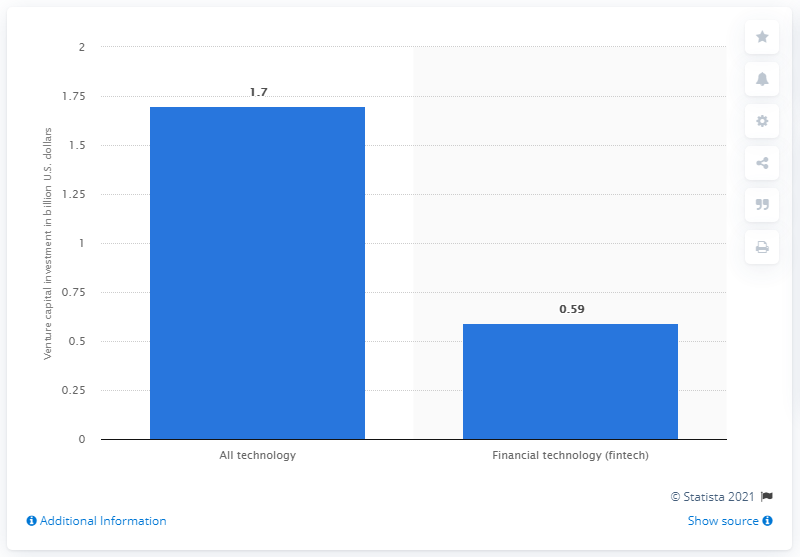Outline some significant characteristics in this image. The total amount of venture capital funding in technology fields in 2021 was approximately 1.7 billion dollars. Financial technology, commonly known as fintech, is another technology aside from all. What is the difference between the two? The first one is "1.11..." and the second one is "1.11... 